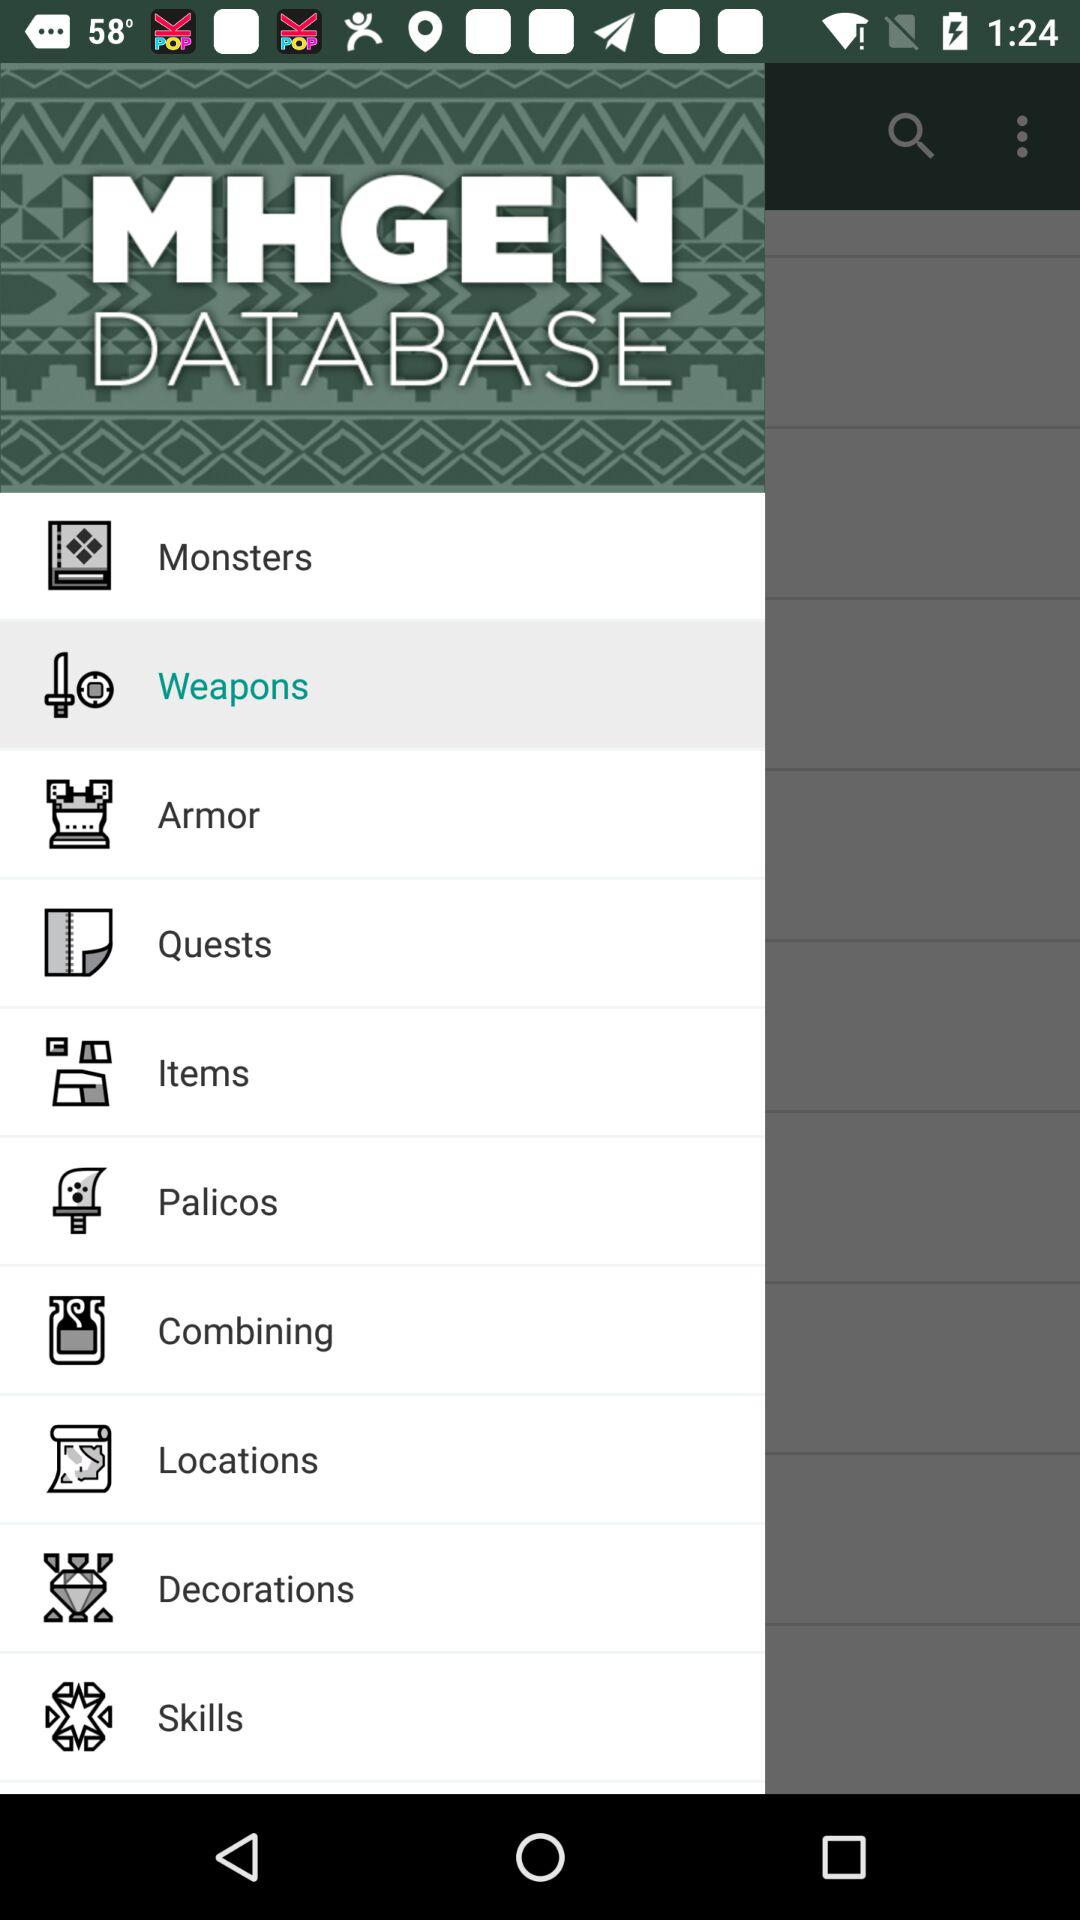What is the app name? The app name is "MHGEN DATABASE". 